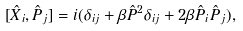<formula> <loc_0><loc_0><loc_500><loc_500>[ \hat { X } _ { i } , \hat { P } _ { j } ] = i ( \delta _ { i j } + \beta \hat { P } ^ { 2 } \delta _ { i j } + 2 \beta \hat { P } _ { i } \hat { P } _ { j } ) ,</formula> 